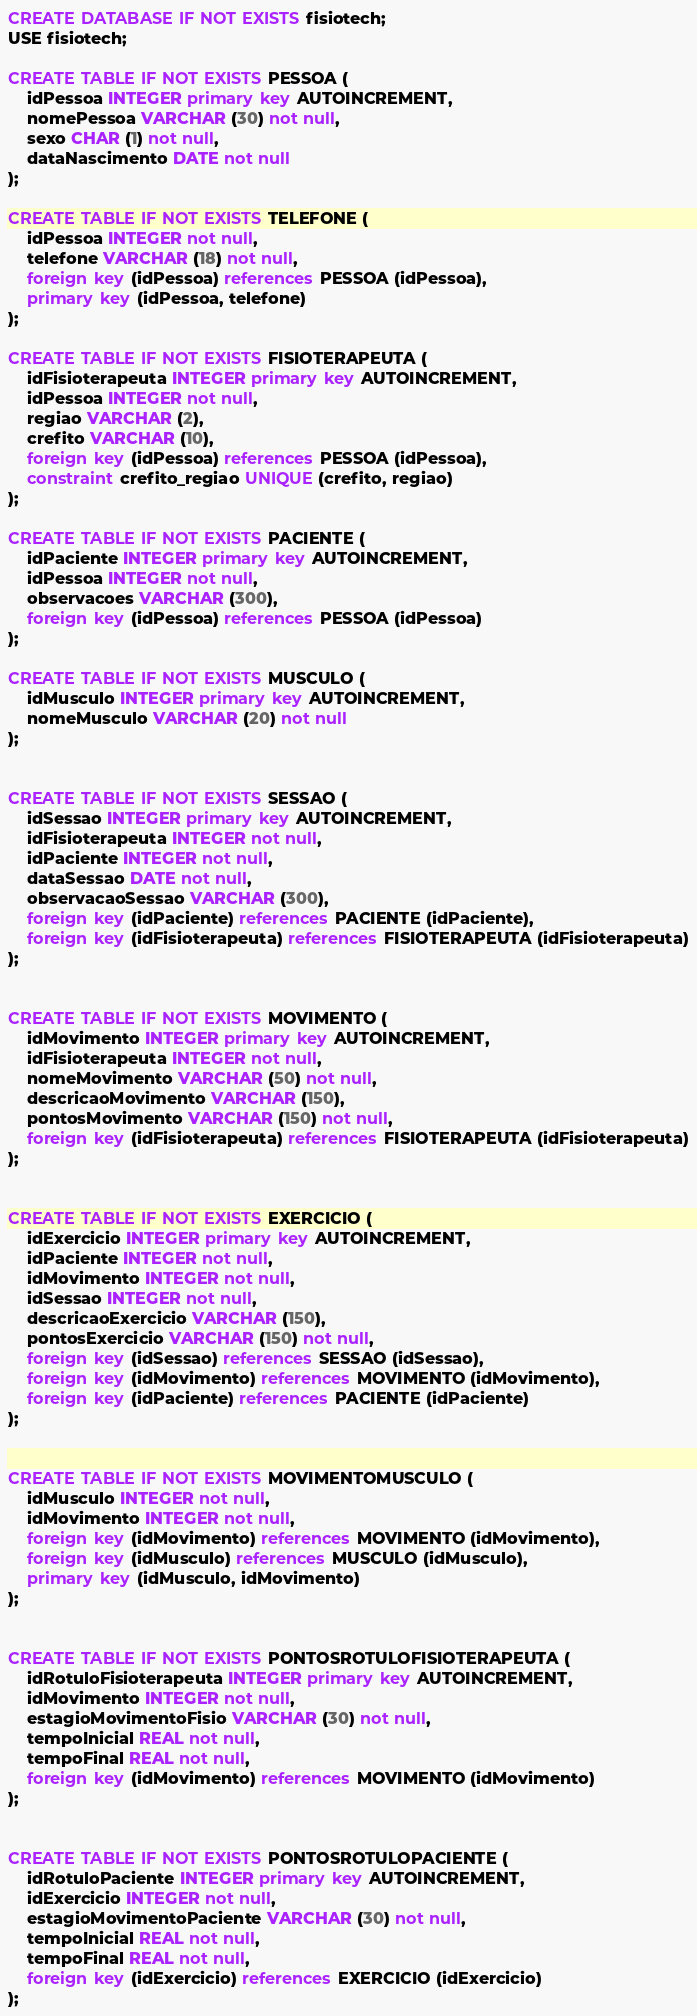Convert code to text. <code><loc_0><loc_0><loc_500><loc_500><_SQL_>
CREATE DATABASE IF NOT EXISTS fisiotech;
USE fisiotech;

CREATE TABLE IF NOT EXISTS PESSOA (
	idPessoa INTEGER primary key AUTOINCREMENT,
	nomePessoa VARCHAR (30) not null,
	sexo CHAR (1) not null,
	dataNascimento DATE not null
);

CREATE TABLE IF NOT EXISTS TELEFONE (
	idPessoa INTEGER not null,
	telefone VARCHAR (18) not null,
	foreign key (idPessoa) references PESSOA (idPessoa),
	primary key (idPessoa, telefone)
);

CREATE TABLE IF NOT EXISTS FISIOTERAPEUTA (
	idFisioterapeuta INTEGER primary key AUTOINCREMENT,
	idPessoa INTEGER not null,
	regiao VARCHAR (2),
	crefito VARCHAR (10),
	foreign key (idPessoa) references PESSOA (idPessoa),
	constraint crefito_regiao UNIQUE (crefito, regiao)
);

CREATE TABLE IF NOT EXISTS PACIENTE (
	idPaciente INTEGER primary key AUTOINCREMENT,
	idPessoa INTEGER not null,
	observacoes VARCHAR (300),
	foreign key (idPessoa) references PESSOA (idPessoa)
);

CREATE TABLE IF NOT EXISTS MUSCULO (
	idMusculo INTEGER primary key AUTOINCREMENT,
	nomeMusculo VARCHAR (20) not null
);


CREATE TABLE IF NOT EXISTS SESSAO (
	idSessao INTEGER primary key AUTOINCREMENT,
	idFisioterapeuta INTEGER not null,
	idPaciente INTEGER not null,
	dataSessao DATE not null,
	observacaoSessao VARCHAR (300),
	foreign key (idPaciente) references PACIENTE (idPaciente),
	foreign key (idFisioterapeuta) references FISIOTERAPEUTA (idFisioterapeuta)
);


CREATE TABLE IF NOT EXISTS MOVIMENTO (
	idMovimento INTEGER primary key AUTOINCREMENT,
	idFisioterapeuta INTEGER not null,
	nomeMovimento VARCHAR (50) not null,
	descricaoMovimento VARCHAR (150),
	pontosMovimento VARCHAR (150) not null,
	foreign key (idFisioterapeuta) references FISIOTERAPEUTA (idFisioterapeuta)
);


CREATE TABLE IF NOT EXISTS EXERCICIO (
	idExercicio INTEGER primary key AUTOINCREMENT,
	idPaciente INTEGER not null,
	idMovimento INTEGER not null,
	idSessao INTEGER not null,
	descricaoExercicio VARCHAR (150),
	pontosExercicio VARCHAR (150) not null,
	foreign key (idSessao) references SESSAO (idSessao),
	foreign key (idMovimento) references MOVIMENTO (idMovimento),
	foreign key (idPaciente) references PACIENTE (idPaciente)
);


CREATE TABLE IF NOT EXISTS MOVIMENTOMUSCULO (
	idMusculo INTEGER not null,
	idMovimento INTEGER not null, 
	foreign key (idMovimento) references MOVIMENTO (idMovimento),
	foreign key (idMusculo) references MUSCULO (idMusculo),
	primary key (idMusculo, idMovimento)
);


CREATE TABLE IF NOT EXISTS PONTOSROTULOFISIOTERAPEUTA (
	idRotuloFisioterapeuta INTEGER primary key AUTOINCREMENT,
	idMovimento INTEGER not null,
	estagioMovimentoFisio VARCHAR (30) not null,
	tempoInicial REAL not null,
	tempoFinal REAL not null,
	foreign key (idMovimento) references MOVIMENTO (idMovimento)
);


CREATE TABLE IF NOT EXISTS PONTOSROTULOPACIENTE (
	idRotuloPaciente INTEGER primary key AUTOINCREMENT,
	idExercicio INTEGER not null,
	estagioMovimentoPaciente VARCHAR (30) not null,
	tempoInicial REAL not null,
	tempoFinal REAL not null,
	foreign key (idExercicio) references EXERCICIO (idExercicio)
);
</code> 